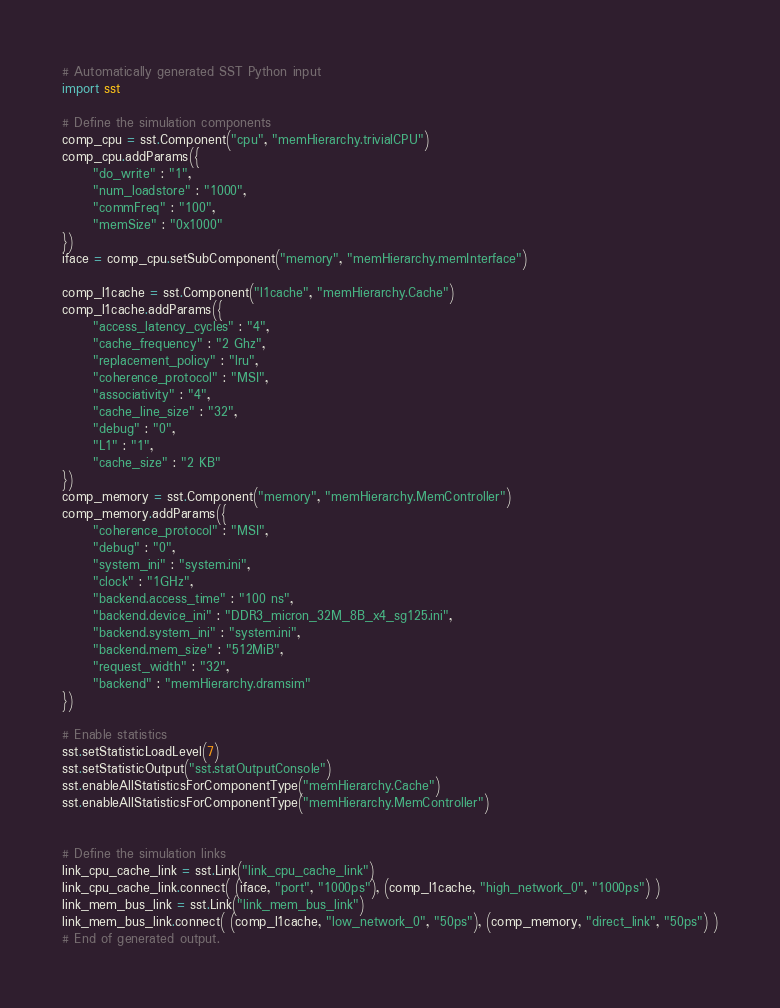Convert code to text. <code><loc_0><loc_0><loc_500><loc_500><_Python_># Automatically generated SST Python input
import sst

# Define the simulation components
comp_cpu = sst.Component("cpu", "memHierarchy.trivialCPU")
comp_cpu.addParams({
      "do_write" : "1",
      "num_loadstore" : "1000",
      "commFreq" : "100",
      "memSize" : "0x1000"
})
iface = comp_cpu.setSubComponent("memory", "memHierarchy.memInterface")

comp_l1cache = sst.Component("l1cache", "memHierarchy.Cache")
comp_l1cache.addParams({
      "access_latency_cycles" : "4",
      "cache_frequency" : "2 Ghz",
      "replacement_policy" : "lru",
      "coherence_protocol" : "MSI",
      "associativity" : "4",
      "cache_line_size" : "32",
      "debug" : "0",
      "L1" : "1",
      "cache_size" : "2 KB"
})
comp_memory = sst.Component("memory", "memHierarchy.MemController")
comp_memory.addParams({
      "coherence_protocol" : "MSI",
      "debug" : "0",
      "system_ini" : "system.ini",
      "clock" : "1GHz",
      "backend.access_time" : "100 ns",
      "backend.device_ini" : "DDR3_micron_32M_8B_x4_sg125.ini",
      "backend.system_ini" : "system.ini",
      "backend.mem_size" : "512MiB",
      "request_width" : "32",
      "backend" : "memHierarchy.dramsim"
})

# Enable statistics
sst.setStatisticLoadLevel(7)
sst.setStatisticOutput("sst.statOutputConsole")
sst.enableAllStatisticsForComponentType("memHierarchy.Cache")
sst.enableAllStatisticsForComponentType("memHierarchy.MemController")


# Define the simulation links
link_cpu_cache_link = sst.Link("link_cpu_cache_link")
link_cpu_cache_link.connect( (iface, "port", "1000ps"), (comp_l1cache, "high_network_0", "1000ps") )
link_mem_bus_link = sst.Link("link_mem_bus_link")
link_mem_bus_link.connect( (comp_l1cache, "low_network_0", "50ps"), (comp_memory, "direct_link", "50ps") )
# End of generated output.
</code> 